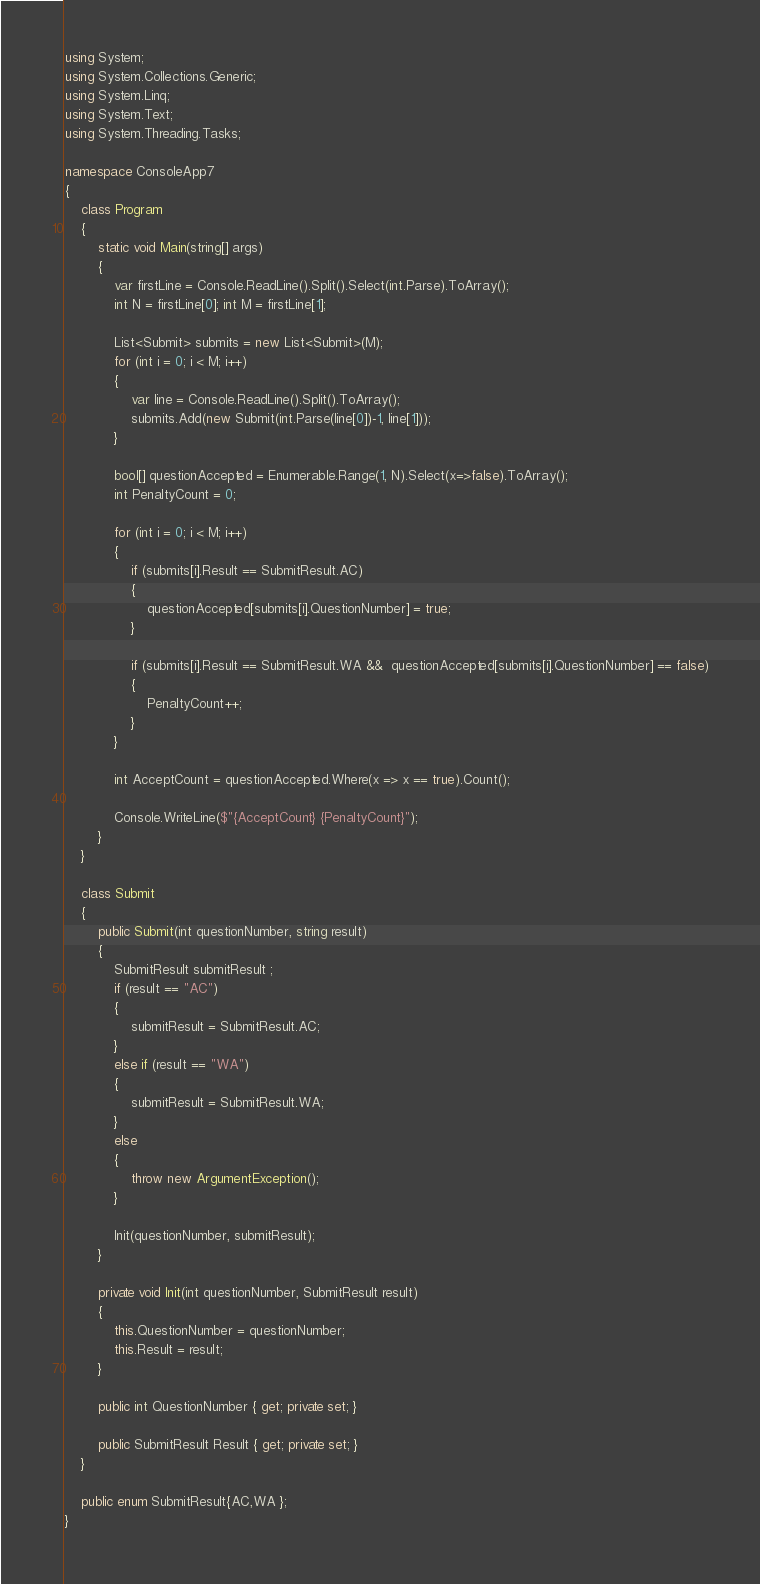<code> <loc_0><loc_0><loc_500><loc_500><_C#_>using System;
using System.Collections.Generic;
using System.Linq;
using System.Text;
using System.Threading.Tasks;

namespace ConsoleApp7
{
    class Program
    {
        static void Main(string[] args)
        {
            var firstLine = Console.ReadLine().Split().Select(int.Parse).ToArray();
            int N = firstLine[0]; int M = firstLine[1];

            List<Submit> submits = new List<Submit>(M);
            for (int i = 0; i < M; i++)
            {
                var line = Console.ReadLine().Split().ToArray();
                submits.Add(new Submit(int.Parse(line[0])-1, line[1]));
            }

            bool[] questionAccepted = Enumerable.Range(1, N).Select(x=>false).ToArray();
            int PenaltyCount = 0;

            for (int i = 0; i < M; i++)
            {
                if (submits[i].Result == SubmitResult.AC)
                {
                    questionAccepted[submits[i].QuestionNumber] = true;
                }

                if (submits[i].Result == SubmitResult.WA &&  questionAccepted[submits[i].QuestionNumber] == false)
                {
                    PenaltyCount++;
                }
            }

            int AcceptCount = questionAccepted.Where(x => x == true).Count();

            Console.WriteLine($"{AcceptCount} {PenaltyCount}");
        }
    }

    class Submit
    {
        public Submit(int questionNumber, string result)
        {
            SubmitResult submitResult ;
            if (result == "AC")
            {
                submitResult = SubmitResult.AC;
            }
            else if (result == "WA")
            {
                submitResult = SubmitResult.WA;
            }
            else
            {
                throw new ArgumentException();
            }

            Init(questionNumber, submitResult);
        }

        private void Init(int questionNumber, SubmitResult result)
        {
            this.QuestionNumber = questionNumber;
            this.Result = result;
        }

        public int QuestionNumber { get; private set; }

        public SubmitResult Result { get; private set; }
    }

    public enum SubmitResult{AC,WA };
}
</code> 